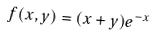Convert formula to latex. <formula><loc_0><loc_0><loc_500><loc_500>f ( x , y ) = ( x + y ) e ^ { - x }</formula> 